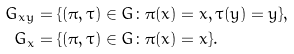<formula> <loc_0><loc_0><loc_500><loc_500>G _ { x y } & = \{ ( \pi , \tau ) \in G \colon \pi ( x ) = x , \tau ( y ) = y \} , \\ G _ { x } & = \{ ( \pi , \tau ) \in G \colon \pi ( x ) = x \} .</formula> 